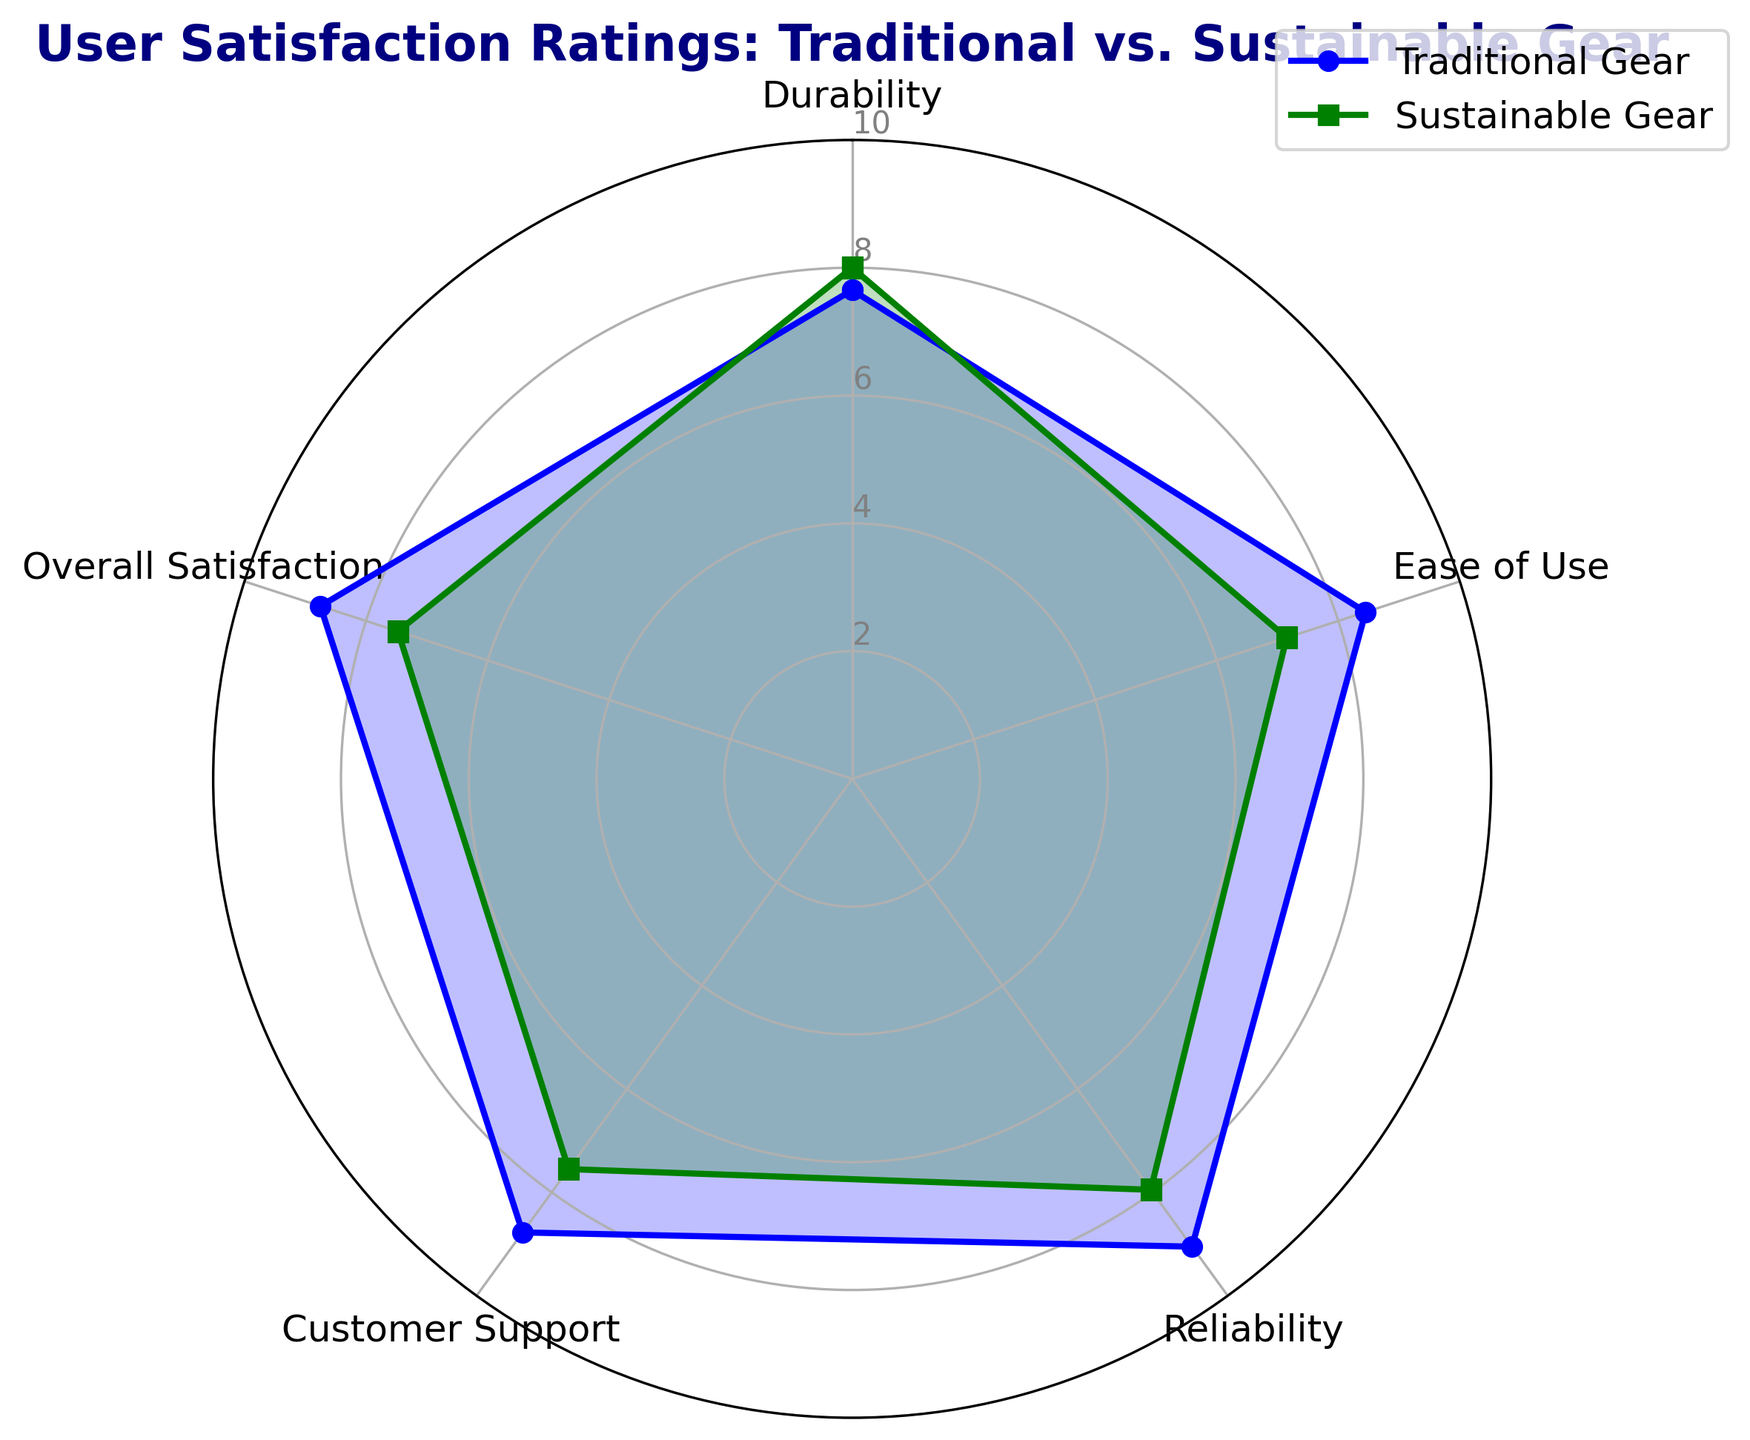Which category shows the highest user satisfaction for Traditional Gear? To find the category with the highest user satisfaction for Traditional Gear, look at the outermost blue line peaks. The topmost value is at "Ease of Use," indicating the highest rating.
Answer: Ease of Use Which category shows the lowest user satisfaction for Sustainable Gear? Examine the green line for the point closest to the center. "Durability" is the innermost and therefore has the lowest rating.
Answer: Durability What is the average user satisfaction rating for Traditional Gear across all categories? Calculate the mean of the Traditional Gear ratings in all categories by summing the scores and dividing by the number of categories: (8.45 + 9.05 + 8.75 + 7.65 + 8.775)/5 = 42.625/5.
Answer: 8.53 How does the overall satisfaction of Traditional Gear compare to Sustainable Gear? Compare the blue and green lines at "Overall Satisfaction." The blue line (Traditional Gear) is clearly further from the center than the green line (Sustainable Gear), implying higher satisfaction.
Answer: Traditional Gear is higher By how much does the "Ease of Use" rating for Traditional Gear exceed that of Sustainable Gear? Look at the "Ease of Use" ratings for both: Traditional Gear is at 9.05 and Sustainable Gear is at 8.0. Subtract the latter from the former: 9.05 - 8.0 = 1.05.
Answer: 1.05 Is Customer Support rating higher for Traditional Gear or Sustainable Gear? Compare the blue and green lines at "Customer Support." The green line (Sustainable Gear) is further from the center than the blue line (Traditional Gear), indicating higher satisfaction.
Answer: Sustainable Gear Calculate the difference in "Reliability" ratings between Traditional and Sustainable Gear. The "Reliability" rating for Traditional Gear is 8.75, and for Sustainable Gear, it is 7.475. Subtract Sustainable Gear from Traditional Gear: 8.75 - 7.475 = 1.275.
Answer: 1.275 Which gear type has more consistently high ratings across categories? Evaluate the spread of both lines. The blue line (Traditional Gear) stays closer to the outer edge across more categories, meaning it's more consistently high.
Answer: Traditional Gear What visual feature indicates higher ratings on the radar chart? In a radar chart, data points further away from the center indicate higher ratings. Therefore, categories where the lines are further from the center are those with higher ratings.
Answer: Distance from the center Which category shows the least difference between Traditional and Sustainable Gear ratings? Determine the category where the blue and green lines are closest. This occurs at "Customer Support," where the ratings are nearly alike.
Answer: Customer Support 